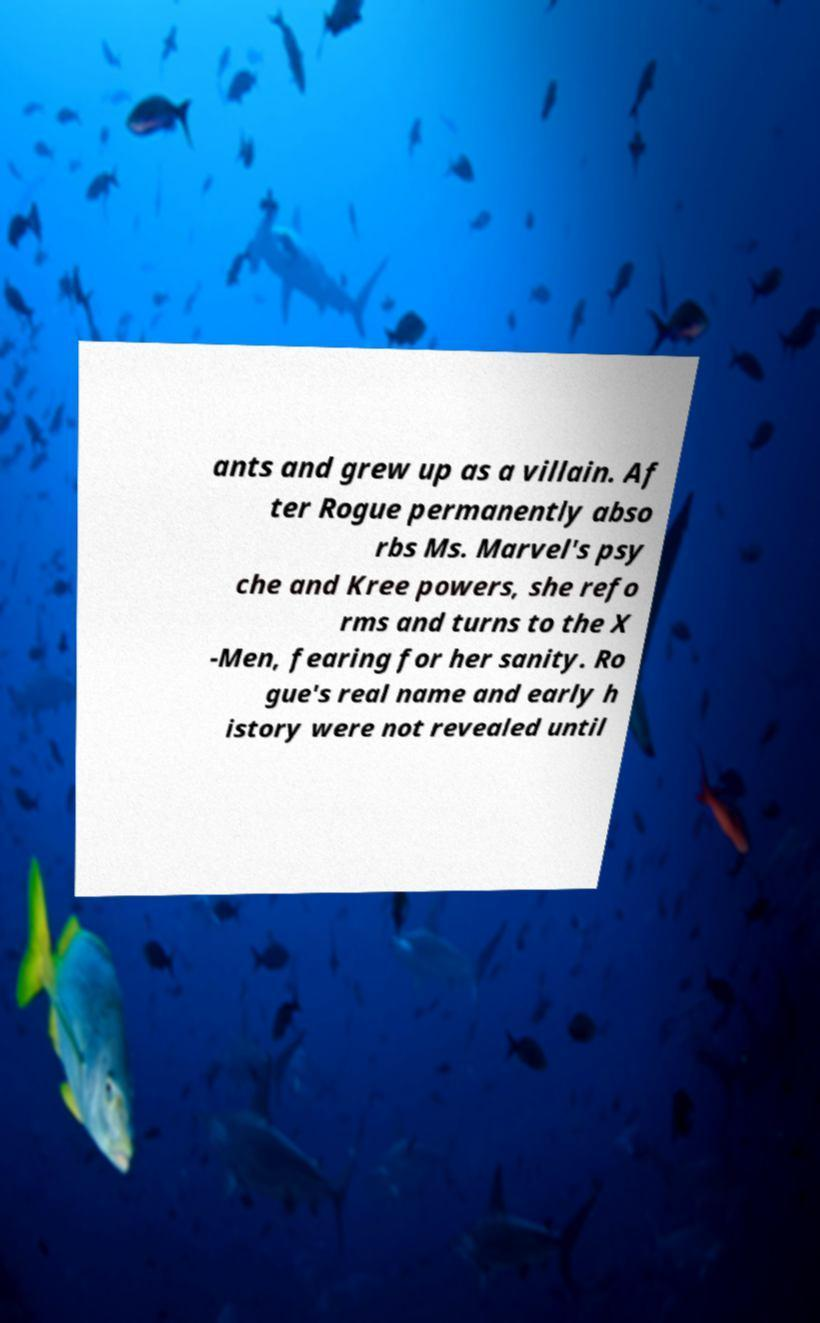Can you read and provide the text displayed in the image?This photo seems to have some interesting text. Can you extract and type it out for me? ants and grew up as a villain. Af ter Rogue permanently abso rbs Ms. Marvel's psy che and Kree powers, she refo rms and turns to the X -Men, fearing for her sanity. Ro gue's real name and early h istory were not revealed until 